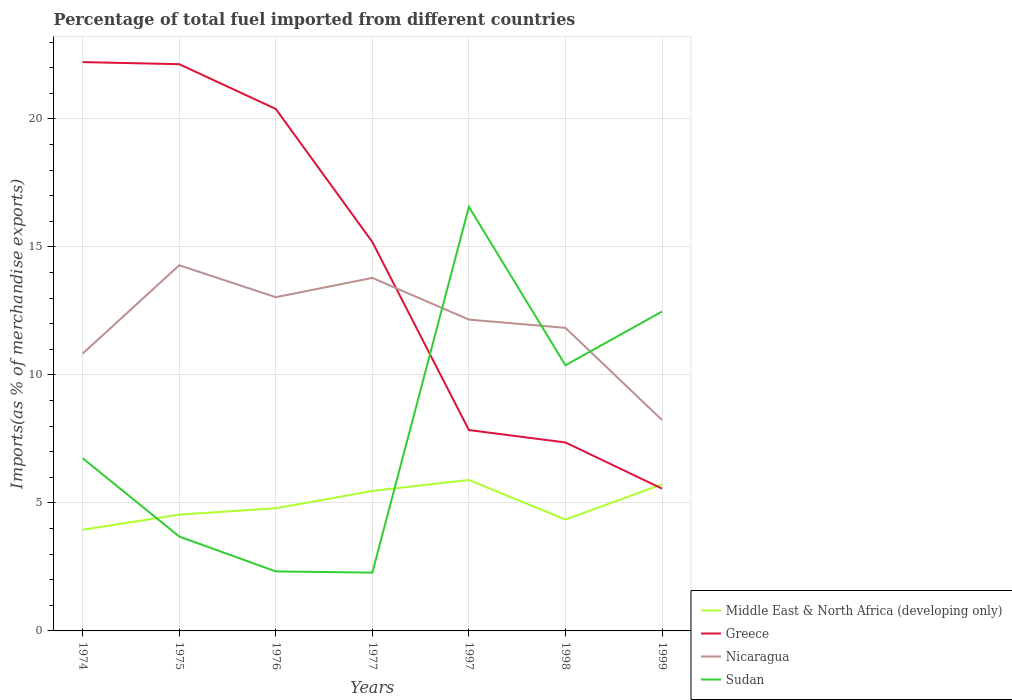How many different coloured lines are there?
Give a very brief answer. 4. Does the line corresponding to Sudan intersect with the line corresponding to Greece?
Your response must be concise. Yes. Is the number of lines equal to the number of legend labels?
Offer a very short reply. Yes. Across all years, what is the maximum percentage of imports to different countries in Nicaragua?
Your answer should be compact. 8.24. In which year was the percentage of imports to different countries in Nicaragua maximum?
Make the answer very short. 1999. What is the total percentage of imports to different countries in Nicaragua in the graph?
Your answer should be very brief. 1.25. What is the difference between the highest and the second highest percentage of imports to different countries in Middle East & North Africa (developing only)?
Offer a very short reply. 1.94. Is the percentage of imports to different countries in Greece strictly greater than the percentage of imports to different countries in Sudan over the years?
Make the answer very short. No. What is the difference between two consecutive major ticks on the Y-axis?
Make the answer very short. 5. Does the graph contain any zero values?
Make the answer very short. No. What is the title of the graph?
Provide a succinct answer. Percentage of total fuel imported from different countries. Does "Egypt, Arab Rep." appear as one of the legend labels in the graph?
Give a very brief answer. No. What is the label or title of the Y-axis?
Provide a succinct answer. Imports(as % of merchandise exports). What is the Imports(as % of merchandise exports) in Middle East & North Africa (developing only) in 1974?
Give a very brief answer. 3.95. What is the Imports(as % of merchandise exports) of Greece in 1974?
Offer a very short reply. 22.22. What is the Imports(as % of merchandise exports) of Nicaragua in 1974?
Your response must be concise. 10.83. What is the Imports(as % of merchandise exports) of Sudan in 1974?
Give a very brief answer. 6.75. What is the Imports(as % of merchandise exports) in Middle East & North Africa (developing only) in 1975?
Your answer should be very brief. 4.54. What is the Imports(as % of merchandise exports) in Greece in 1975?
Your answer should be compact. 22.14. What is the Imports(as % of merchandise exports) of Nicaragua in 1975?
Offer a very short reply. 14.28. What is the Imports(as % of merchandise exports) of Sudan in 1975?
Offer a very short reply. 3.69. What is the Imports(as % of merchandise exports) of Middle East & North Africa (developing only) in 1976?
Make the answer very short. 4.79. What is the Imports(as % of merchandise exports) of Greece in 1976?
Keep it short and to the point. 20.39. What is the Imports(as % of merchandise exports) in Nicaragua in 1976?
Give a very brief answer. 13.04. What is the Imports(as % of merchandise exports) of Sudan in 1976?
Your response must be concise. 2.32. What is the Imports(as % of merchandise exports) of Middle East & North Africa (developing only) in 1977?
Provide a succinct answer. 5.47. What is the Imports(as % of merchandise exports) in Greece in 1977?
Provide a short and direct response. 15.19. What is the Imports(as % of merchandise exports) of Nicaragua in 1977?
Ensure brevity in your answer.  13.79. What is the Imports(as % of merchandise exports) in Sudan in 1977?
Ensure brevity in your answer.  2.28. What is the Imports(as % of merchandise exports) of Middle East & North Africa (developing only) in 1997?
Ensure brevity in your answer.  5.9. What is the Imports(as % of merchandise exports) in Greece in 1997?
Provide a succinct answer. 7.85. What is the Imports(as % of merchandise exports) in Nicaragua in 1997?
Your answer should be very brief. 12.16. What is the Imports(as % of merchandise exports) in Sudan in 1997?
Your response must be concise. 16.57. What is the Imports(as % of merchandise exports) in Middle East & North Africa (developing only) in 1998?
Offer a terse response. 4.35. What is the Imports(as % of merchandise exports) in Greece in 1998?
Your answer should be very brief. 7.36. What is the Imports(as % of merchandise exports) in Nicaragua in 1998?
Give a very brief answer. 11.84. What is the Imports(as % of merchandise exports) in Sudan in 1998?
Your answer should be compact. 10.38. What is the Imports(as % of merchandise exports) of Middle East & North Africa (developing only) in 1999?
Offer a very short reply. 5.72. What is the Imports(as % of merchandise exports) in Greece in 1999?
Offer a very short reply. 5.56. What is the Imports(as % of merchandise exports) of Nicaragua in 1999?
Give a very brief answer. 8.24. What is the Imports(as % of merchandise exports) of Sudan in 1999?
Offer a very short reply. 12.48. Across all years, what is the maximum Imports(as % of merchandise exports) in Middle East & North Africa (developing only)?
Offer a very short reply. 5.9. Across all years, what is the maximum Imports(as % of merchandise exports) of Greece?
Your answer should be very brief. 22.22. Across all years, what is the maximum Imports(as % of merchandise exports) in Nicaragua?
Your answer should be compact. 14.28. Across all years, what is the maximum Imports(as % of merchandise exports) of Sudan?
Your answer should be compact. 16.57. Across all years, what is the minimum Imports(as % of merchandise exports) in Middle East & North Africa (developing only)?
Your answer should be very brief. 3.95. Across all years, what is the minimum Imports(as % of merchandise exports) of Greece?
Your answer should be compact. 5.56. Across all years, what is the minimum Imports(as % of merchandise exports) of Nicaragua?
Ensure brevity in your answer.  8.24. Across all years, what is the minimum Imports(as % of merchandise exports) of Sudan?
Provide a short and direct response. 2.28. What is the total Imports(as % of merchandise exports) of Middle East & North Africa (developing only) in the graph?
Your response must be concise. 34.73. What is the total Imports(as % of merchandise exports) in Greece in the graph?
Keep it short and to the point. 100.71. What is the total Imports(as % of merchandise exports) of Nicaragua in the graph?
Ensure brevity in your answer.  84.18. What is the total Imports(as % of merchandise exports) in Sudan in the graph?
Make the answer very short. 54.45. What is the difference between the Imports(as % of merchandise exports) of Middle East & North Africa (developing only) in 1974 and that in 1975?
Ensure brevity in your answer.  -0.59. What is the difference between the Imports(as % of merchandise exports) of Greece in 1974 and that in 1975?
Make the answer very short. 0.08. What is the difference between the Imports(as % of merchandise exports) in Nicaragua in 1974 and that in 1975?
Your answer should be compact. -3.45. What is the difference between the Imports(as % of merchandise exports) in Sudan in 1974 and that in 1975?
Your response must be concise. 3.06. What is the difference between the Imports(as % of merchandise exports) of Middle East & North Africa (developing only) in 1974 and that in 1976?
Your answer should be very brief. -0.84. What is the difference between the Imports(as % of merchandise exports) in Greece in 1974 and that in 1976?
Your response must be concise. 1.83. What is the difference between the Imports(as % of merchandise exports) of Nicaragua in 1974 and that in 1976?
Provide a succinct answer. -2.2. What is the difference between the Imports(as % of merchandise exports) in Sudan in 1974 and that in 1976?
Make the answer very short. 4.42. What is the difference between the Imports(as % of merchandise exports) of Middle East & North Africa (developing only) in 1974 and that in 1977?
Keep it short and to the point. -1.51. What is the difference between the Imports(as % of merchandise exports) of Greece in 1974 and that in 1977?
Ensure brevity in your answer.  7.03. What is the difference between the Imports(as % of merchandise exports) in Nicaragua in 1974 and that in 1977?
Your answer should be very brief. -2.96. What is the difference between the Imports(as % of merchandise exports) in Sudan in 1974 and that in 1977?
Provide a succinct answer. 4.47. What is the difference between the Imports(as % of merchandise exports) of Middle East & North Africa (developing only) in 1974 and that in 1997?
Your answer should be compact. -1.94. What is the difference between the Imports(as % of merchandise exports) in Greece in 1974 and that in 1997?
Provide a succinct answer. 14.37. What is the difference between the Imports(as % of merchandise exports) in Nicaragua in 1974 and that in 1997?
Ensure brevity in your answer.  -1.33. What is the difference between the Imports(as % of merchandise exports) of Sudan in 1974 and that in 1997?
Your answer should be compact. -9.82. What is the difference between the Imports(as % of merchandise exports) in Middle East & North Africa (developing only) in 1974 and that in 1998?
Your answer should be compact. -0.4. What is the difference between the Imports(as % of merchandise exports) of Greece in 1974 and that in 1998?
Provide a short and direct response. 14.86. What is the difference between the Imports(as % of merchandise exports) of Nicaragua in 1974 and that in 1998?
Offer a very short reply. -1. What is the difference between the Imports(as % of merchandise exports) of Sudan in 1974 and that in 1998?
Provide a succinct answer. -3.63. What is the difference between the Imports(as % of merchandise exports) in Middle East & North Africa (developing only) in 1974 and that in 1999?
Your answer should be very brief. -1.77. What is the difference between the Imports(as % of merchandise exports) of Greece in 1974 and that in 1999?
Keep it short and to the point. 16.66. What is the difference between the Imports(as % of merchandise exports) in Nicaragua in 1974 and that in 1999?
Provide a succinct answer. 2.6. What is the difference between the Imports(as % of merchandise exports) of Sudan in 1974 and that in 1999?
Offer a very short reply. -5.73. What is the difference between the Imports(as % of merchandise exports) of Middle East & North Africa (developing only) in 1975 and that in 1976?
Provide a succinct answer. -0.25. What is the difference between the Imports(as % of merchandise exports) of Greece in 1975 and that in 1976?
Offer a very short reply. 1.75. What is the difference between the Imports(as % of merchandise exports) in Nicaragua in 1975 and that in 1976?
Your response must be concise. 1.25. What is the difference between the Imports(as % of merchandise exports) of Sudan in 1975 and that in 1976?
Keep it short and to the point. 1.36. What is the difference between the Imports(as % of merchandise exports) in Middle East & North Africa (developing only) in 1975 and that in 1977?
Ensure brevity in your answer.  -0.92. What is the difference between the Imports(as % of merchandise exports) in Greece in 1975 and that in 1977?
Your answer should be compact. 6.94. What is the difference between the Imports(as % of merchandise exports) in Nicaragua in 1975 and that in 1977?
Keep it short and to the point. 0.49. What is the difference between the Imports(as % of merchandise exports) of Sudan in 1975 and that in 1977?
Offer a terse response. 1.41. What is the difference between the Imports(as % of merchandise exports) in Middle East & North Africa (developing only) in 1975 and that in 1997?
Give a very brief answer. -1.35. What is the difference between the Imports(as % of merchandise exports) of Greece in 1975 and that in 1997?
Make the answer very short. 14.29. What is the difference between the Imports(as % of merchandise exports) of Nicaragua in 1975 and that in 1997?
Ensure brevity in your answer.  2.12. What is the difference between the Imports(as % of merchandise exports) of Sudan in 1975 and that in 1997?
Keep it short and to the point. -12.88. What is the difference between the Imports(as % of merchandise exports) of Middle East & North Africa (developing only) in 1975 and that in 1998?
Provide a succinct answer. 0.19. What is the difference between the Imports(as % of merchandise exports) of Greece in 1975 and that in 1998?
Your answer should be compact. 14.78. What is the difference between the Imports(as % of merchandise exports) in Nicaragua in 1975 and that in 1998?
Make the answer very short. 2.45. What is the difference between the Imports(as % of merchandise exports) in Sudan in 1975 and that in 1998?
Provide a short and direct response. -6.69. What is the difference between the Imports(as % of merchandise exports) in Middle East & North Africa (developing only) in 1975 and that in 1999?
Give a very brief answer. -1.18. What is the difference between the Imports(as % of merchandise exports) of Greece in 1975 and that in 1999?
Your answer should be very brief. 16.58. What is the difference between the Imports(as % of merchandise exports) in Nicaragua in 1975 and that in 1999?
Offer a very short reply. 6.05. What is the difference between the Imports(as % of merchandise exports) in Sudan in 1975 and that in 1999?
Offer a very short reply. -8.79. What is the difference between the Imports(as % of merchandise exports) in Middle East & North Africa (developing only) in 1976 and that in 1977?
Give a very brief answer. -0.68. What is the difference between the Imports(as % of merchandise exports) in Greece in 1976 and that in 1977?
Your response must be concise. 5.2. What is the difference between the Imports(as % of merchandise exports) in Nicaragua in 1976 and that in 1977?
Offer a very short reply. -0.75. What is the difference between the Imports(as % of merchandise exports) of Sudan in 1976 and that in 1977?
Provide a succinct answer. 0.05. What is the difference between the Imports(as % of merchandise exports) in Middle East & North Africa (developing only) in 1976 and that in 1997?
Ensure brevity in your answer.  -1.11. What is the difference between the Imports(as % of merchandise exports) in Greece in 1976 and that in 1997?
Provide a succinct answer. 12.54. What is the difference between the Imports(as % of merchandise exports) of Nicaragua in 1976 and that in 1997?
Provide a short and direct response. 0.88. What is the difference between the Imports(as % of merchandise exports) of Sudan in 1976 and that in 1997?
Your response must be concise. -14.24. What is the difference between the Imports(as % of merchandise exports) in Middle East & North Africa (developing only) in 1976 and that in 1998?
Offer a very short reply. 0.44. What is the difference between the Imports(as % of merchandise exports) in Greece in 1976 and that in 1998?
Offer a very short reply. 13.03. What is the difference between the Imports(as % of merchandise exports) of Nicaragua in 1976 and that in 1998?
Provide a succinct answer. 1.2. What is the difference between the Imports(as % of merchandise exports) in Sudan in 1976 and that in 1998?
Provide a succinct answer. -8.05. What is the difference between the Imports(as % of merchandise exports) in Middle East & North Africa (developing only) in 1976 and that in 1999?
Make the answer very short. -0.93. What is the difference between the Imports(as % of merchandise exports) of Greece in 1976 and that in 1999?
Your answer should be compact. 14.83. What is the difference between the Imports(as % of merchandise exports) in Nicaragua in 1976 and that in 1999?
Provide a succinct answer. 4.8. What is the difference between the Imports(as % of merchandise exports) of Sudan in 1976 and that in 1999?
Give a very brief answer. -10.15. What is the difference between the Imports(as % of merchandise exports) in Middle East & North Africa (developing only) in 1977 and that in 1997?
Provide a short and direct response. -0.43. What is the difference between the Imports(as % of merchandise exports) of Greece in 1977 and that in 1997?
Offer a very short reply. 7.35. What is the difference between the Imports(as % of merchandise exports) in Nicaragua in 1977 and that in 1997?
Your answer should be very brief. 1.63. What is the difference between the Imports(as % of merchandise exports) in Sudan in 1977 and that in 1997?
Make the answer very short. -14.29. What is the difference between the Imports(as % of merchandise exports) in Middle East & North Africa (developing only) in 1977 and that in 1998?
Your answer should be very brief. 1.12. What is the difference between the Imports(as % of merchandise exports) of Greece in 1977 and that in 1998?
Make the answer very short. 7.83. What is the difference between the Imports(as % of merchandise exports) in Nicaragua in 1977 and that in 1998?
Offer a very short reply. 1.95. What is the difference between the Imports(as % of merchandise exports) of Sudan in 1977 and that in 1998?
Offer a very short reply. -8.1. What is the difference between the Imports(as % of merchandise exports) in Middle East & North Africa (developing only) in 1977 and that in 1999?
Your response must be concise. -0.26. What is the difference between the Imports(as % of merchandise exports) of Greece in 1977 and that in 1999?
Offer a terse response. 9.63. What is the difference between the Imports(as % of merchandise exports) of Nicaragua in 1977 and that in 1999?
Provide a succinct answer. 5.55. What is the difference between the Imports(as % of merchandise exports) of Sudan in 1977 and that in 1999?
Offer a very short reply. -10.2. What is the difference between the Imports(as % of merchandise exports) in Middle East & North Africa (developing only) in 1997 and that in 1998?
Ensure brevity in your answer.  1.55. What is the difference between the Imports(as % of merchandise exports) of Greece in 1997 and that in 1998?
Provide a short and direct response. 0.48. What is the difference between the Imports(as % of merchandise exports) of Nicaragua in 1997 and that in 1998?
Provide a short and direct response. 0.32. What is the difference between the Imports(as % of merchandise exports) in Sudan in 1997 and that in 1998?
Your answer should be very brief. 6.19. What is the difference between the Imports(as % of merchandise exports) of Middle East & North Africa (developing only) in 1997 and that in 1999?
Offer a terse response. 0.17. What is the difference between the Imports(as % of merchandise exports) of Greece in 1997 and that in 1999?
Offer a terse response. 2.29. What is the difference between the Imports(as % of merchandise exports) in Nicaragua in 1997 and that in 1999?
Ensure brevity in your answer.  3.92. What is the difference between the Imports(as % of merchandise exports) of Sudan in 1997 and that in 1999?
Offer a very short reply. 4.09. What is the difference between the Imports(as % of merchandise exports) of Middle East & North Africa (developing only) in 1998 and that in 1999?
Give a very brief answer. -1.37. What is the difference between the Imports(as % of merchandise exports) of Greece in 1998 and that in 1999?
Ensure brevity in your answer.  1.8. What is the difference between the Imports(as % of merchandise exports) of Nicaragua in 1998 and that in 1999?
Ensure brevity in your answer.  3.6. What is the difference between the Imports(as % of merchandise exports) in Sudan in 1998 and that in 1999?
Keep it short and to the point. -2.1. What is the difference between the Imports(as % of merchandise exports) in Middle East & North Africa (developing only) in 1974 and the Imports(as % of merchandise exports) in Greece in 1975?
Offer a very short reply. -18.18. What is the difference between the Imports(as % of merchandise exports) of Middle East & North Africa (developing only) in 1974 and the Imports(as % of merchandise exports) of Nicaragua in 1975?
Keep it short and to the point. -10.33. What is the difference between the Imports(as % of merchandise exports) in Middle East & North Africa (developing only) in 1974 and the Imports(as % of merchandise exports) in Sudan in 1975?
Keep it short and to the point. 0.27. What is the difference between the Imports(as % of merchandise exports) in Greece in 1974 and the Imports(as % of merchandise exports) in Nicaragua in 1975?
Keep it short and to the point. 7.94. What is the difference between the Imports(as % of merchandise exports) in Greece in 1974 and the Imports(as % of merchandise exports) in Sudan in 1975?
Give a very brief answer. 18.53. What is the difference between the Imports(as % of merchandise exports) of Nicaragua in 1974 and the Imports(as % of merchandise exports) of Sudan in 1975?
Keep it short and to the point. 7.15. What is the difference between the Imports(as % of merchandise exports) of Middle East & North Africa (developing only) in 1974 and the Imports(as % of merchandise exports) of Greece in 1976?
Offer a terse response. -16.44. What is the difference between the Imports(as % of merchandise exports) of Middle East & North Africa (developing only) in 1974 and the Imports(as % of merchandise exports) of Nicaragua in 1976?
Your answer should be very brief. -9.08. What is the difference between the Imports(as % of merchandise exports) in Middle East & North Africa (developing only) in 1974 and the Imports(as % of merchandise exports) in Sudan in 1976?
Offer a very short reply. 1.63. What is the difference between the Imports(as % of merchandise exports) of Greece in 1974 and the Imports(as % of merchandise exports) of Nicaragua in 1976?
Offer a terse response. 9.18. What is the difference between the Imports(as % of merchandise exports) of Greece in 1974 and the Imports(as % of merchandise exports) of Sudan in 1976?
Make the answer very short. 19.89. What is the difference between the Imports(as % of merchandise exports) of Nicaragua in 1974 and the Imports(as % of merchandise exports) of Sudan in 1976?
Provide a short and direct response. 8.51. What is the difference between the Imports(as % of merchandise exports) of Middle East & North Africa (developing only) in 1974 and the Imports(as % of merchandise exports) of Greece in 1977?
Offer a terse response. -11.24. What is the difference between the Imports(as % of merchandise exports) of Middle East & North Africa (developing only) in 1974 and the Imports(as % of merchandise exports) of Nicaragua in 1977?
Give a very brief answer. -9.84. What is the difference between the Imports(as % of merchandise exports) of Middle East & North Africa (developing only) in 1974 and the Imports(as % of merchandise exports) of Sudan in 1977?
Make the answer very short. 1.68. What is the difference between the Imports(as % of merchandise exports) of Greece in 1974 and the Imports(as % of merchandise exports) of Nicaragua in 1977?
Provide a succinct answer. 8.43. What is the difference between the Imports(as % of merchandise exports) of Greece in 1974 and the Imports(as % of merchandise exports) of Sudan in 1977?
Offer a terse response. 19.94. What is the difference between the Imports(as % of merchandise exports) in Nicaragua in 1974 and the Imports(as % of merchandise exports) in Sudan in 1977?
Offer a terse response. 8.56. What is the difference between the Imports(as % of merchandise exports) in Middle East & North Africa (developing only) in 1974 and the Imports(as % of merchandise exports) in Greece in 1997?
Your answer should be compact. -3.89. What is the difference between the Imports(as % of merchandise exports) in Middle East & North Africa (developing only) in 1974 and the Imports(as % of merchandise exports) in Nicaragua in 1997?
Give a very brief answer. -8.21. What is the difference between the Imports(as % of merchandise exports) of Middle East & North Africa (developing only) in 1974 and the Imports(as % of merchandise exports) of Sudan in 1997?
Make the answer very short. -12.61. What is the difference between the Imports(as % of merchandise exports) in Greece in 1974 and the Imports(as % of merchandise exports) in Nicaragua in 1997?
Offer a very short reply. 10.06. What is the difference between the Imports(as % of merchandise exports) of Greece in 1974 and the Imports(as % of merchandise exports) of Sudan in 1997?
Ensure brevity in your answer.  5.65. What is the difference between the Imports(as % of merchandise exports) of Nicaragua in 1974 and the Imports(as % of merchandise exports) of Sudan in 1997?
Provide a short and direct response. -5.73. What is the difference between the Imports(as % of merchandise exports) of Middle East & North Africa (developing only) in 1974 and the Imports(as % of merchandise exports) of Greece in 1998?
Your answer should be compact. -3.41. What is the difference between the Imports(as % of merchandise exports) in Middle East & North Africa (developing only) in 1974 and the Imports(as % of merchandise exports) in Nicaragua in 1998?
Keep it short and to the point. -7.89. What is the difference between the Imports(as % of merchandise exports) in Middle East & North Africa (developing only) in 1974 and the Imports(as % of merchandise exports) in Sudan in 1998?
Ensure brevity in your answer.  -6.42. What is the difference between the Imports(as % of merchandise exports) in Greece in 1974 and the Imports(as % of merchandise exports) in Nicaragua in 1998?
Offer a very short reply. 10.38. What is the difference between the Imports(as % of merchandise exports) in Greece in 1974 and the Imports(as % of merchandise exports) in Sudan in 1998?
Ensure brevity in your answer.  11.84. What is the difference between the Imports(as % of merchandise exports) in Nicaragua in 1974 and the Imports(as % of merchandise exports) in Sudan in 1998?
Your answer should be compact. 0.46. What is the difference between the Imports(as % of merchandise exports) of Middle East & North Africa (developing only) in 1974 and the Imports(as % of merchandise exports) of Greece in 1999?
Make the answer very short. -1.61. What is the difference between the Imports(as % of merchandise exports) of Middle East & North Africa (developing only) in 1974 and the Imports(as % of merchandise exports) of Nicaragua in 1999?
Give a very brief answer. -4.28. What is the difference between the Imports(as % of merchandise exports) in Middle East & North Africa (developing only) in 1974 and the Imports(as % of merchandise exports) in Sudan in 1999?
Your answer should be very brief. -8.52. What is the difference between the Imports(as % of merchandise exports) in Greece in 1974 and the Imports(as % of merchandise exports) in Nicaragua in 1999?
Your response must be concise. 13.98. What is the difference between the Imports(as % of merchandise exports) of Greece in 1974 and the Imports(as % of merchandise exports) of Sudan in 1999?
Provide a succinct answer. 9.74. What is the difference between the Imports(as % of merchandise exports) in Nicaragua in 1974 and the Imports(as % of merchandise exports) in Sudan in 1999?
Keep it short and to the point. -1.64. What is the difference between the Imports(as % of merchandise exports) of Middle East & North Africa (developing only) in 1975 and the Imports(as % of merchandise exports) of Greece in 1976?
Keep it short and to the point. -15.85. What is the difference between the Imports(as % of merchandise exports) in Middle East & North Africa (developing only) in 1975 and the Imports(as % of merchandise exports) in Nicaragua in 1976?
Your response must be concise. -8.49. What is the difference between the Imports(as % of merchandise exports) in Middle East & North Africa (developing only) in 1975 and the Imports(as % of merchandise exports) in Sudan in 1976?
Provide a succinct answer. 2.22. What is the difference between the Imports(as % of merchandise exports) of Greece in 1975 and the Imports(as % of merchandise exports) of Nicaragua in 1976?
Provide a short and direct response. 9.1. What is the difference between the Imports(as % of merchandise exports) in Greece in 1975 and the Imports(as % of merchandise exports) in Sudan in 1976?
Ensure brevity in your answer.  19.81. What is the difference between the Imports(as % of merchandise exports) of Nicaragua in 1975 and the Imports(as % of merchandise exports) of Sudan in 1976?
Give a very brief answer. 11.96. What is the difference between the Imports(as % of merchandise exports) in Middle East & North Africa (developing only) in 1975 and the Imports(as % of merchandise exports) in Greece in 1977?
Make the answer very short. -10.65. What is the difference between the Imports(as % of merchandise exports) of Middle East & North Africa (developing only) in 1975 and the Imports(as % of merchandise exports) of Nicaragua in 1977?
Make the answer very short. -9.25. What is the difference between the Imports(as % of merchandise exports) in Middle East & North Africa (developing only) in 1975 and the Imports(as % of merchandise exports) in Sudan in 1977?
Give a very brief answer. 2.27. What is the difference between the Imports(as % of merchandise exports) of Greece in 1975 and the Imports(as % of merchandise exports) of Nicaragua in 1977?
Ensure brevity in your answer.  8.35. What is the difference between the Imports(as % of merchandise exports) in Greece in 1975 and the Imports(as % of merchandise exports) in Sudan in 1977?
Your answer should be very brief. 19.86. What is the difference between the Imports(as % of merchandise exports) of Nicaragua in 1975 and the Imports(as % of merchandise exports) of Sudan in 1977?
Provide a short and direct response. 12.01. What is the difference between the Imports(as % of merchandise exports) in Middle East & North Africa (developing only) in 1975 and the Imports(as % of merchandise exports) in Greece in 1997?
Your answer should be compact. -3.3. What is the difference between the Imports(as % of merchandise exports) of Middle East & North Africa (developing only) in 1975 and the Imports(as % of merchandise exports) of Nicaragua in 1997?
Your response must be concise. -7.62. What is the difference between the Imports(as % of merchandise exports) of Middle East & North Africa (developing only) in 1975 and the Imports(as % of merchandise exports) of Sudan in 1997?
Provide a short and direct response. -12.02. What is the difference between the Imports(as % of merchandise exports) of Greece in 1975 and the Imports(as % of merchandise exports) of Nicaragua in 1997?
Make the answer very short. 9.98. What is the difference between the Imports(as % of merchandise exports) in Greece in 1975 and the Imports(as % of merchandise exports) in Sudan in 1997?
Make the answer very short. 5.57. What is the difference between the Imports(as % of merchandise exports) in Nicaragua in 1975 and the Imports(as % of merchandise exports) in Sudan in 1997?
Provide a succinct answer. -2.28. What is the difference between the Imports(as % of merchandise exports) in Middle East & North Africa (developing only) in 1975 and the Imports(as % of merchandise exports) in Greece in 1998?
Keep it short and to the point. -2.82. What is the difference between the Imports(as % of merchandise exports) of Middle East & North Africa (developing only) in 1975 and the Imports(as % of merchandise exports) of Nicaragua in 1998?
Your answer should be compact. -7.3. What is the difference between the Imports(as % of merchandise exports) in Middle East & North Africa (developing only) in 1975 and the Imports(as % of merchandise exports) in Sudan in 1998?
Make the answer very short. -5.83. What is the difference between the Imports(as % of merchandise exports) of Greece in 1975 and the Imports(as % of merchandise exports) of Nicaragua in 1998?
Provide a short and direct response. 10.3. What is the difference between the Imports(as % of merchandise exports) in Greece in 1975 and the Imports(as % of merchandise exports) in Sudan in 1998?
Give a very brief answer. 11.76. What is the difference between the Imports(as % of merchandise exports) in Nicaragua in 1975 and the Imports(as % of merchandise exports) in Sudan in 1998?
Your answer should be compact. 3.91. What is the difference between the Imports(as % of merchandise exports) of Middle East & North Africa (developing only) in 1975 and the Imports(as % of merchandise exports) of Greece in 1999?
Offer a very short reply. -1.02. What is the difference between the Imports(as % of merchandise exports) in Middle East & North Africa (developing only) in 1975 and the Imports(as % of merchandise exports) in Nicaragua in 1999?
Ensure brevity in your answer.  -3.7. What is the difference between the Imports(as % of merchandise exports) in Middle East & North Africa (developing only) in 1975 and the Imports(as % of merchandise exports) in Sudan in 1999?
Give a very brief answer. -7.93. What is the difference between the Imports(as % of merchandise exports) of Greece in 1975 and the Imports(as % of merchandise exports) of Nicaragua in 1999?
Keep it short and to the point. 13.9. What is the difference between the Imports(as % of merchandise exports) in Greece in 1975 and the Imports(as % of merchandise exports) in Sudan in 1999?
Give a very brief answer. 9.66. What is the difference between the Imports(as % of merchandise exports) in Nicaragua in 1975 and the Imports(as % of merchandise exports) in Sudan in 1999?
Provide a short and direct response. 1.81. What is the difference between the Imports(as % of merchandise exports) of Middle East & North Africa (developing only) in 1976 and the Imports(as % of merchandise exports) of Greece in 1977?
Give a very brief answer. -10.4. What is the difference between the Imports(as % of merchandise exports) in Middle East & North Africa (developing only) in 1976 and the Imports(as % of merchandise exports) in Nicaragua in 1977?
Your response must be concise. -9. What is the difference between the Imports(as % of merchandise exports) in Middle East & North Africa (developing only) in 1976 and the Imports(as % of merchandise exports) in Sudan in 1977?
Your response must be concise. 2.51. What is the difference between the Imports(as % of merchandise exports) in Greece in 1976 and the Imports(as % of merchandise exports) in Nicaragua in 1977?
Keep it short and to the point. 6.6. What is the difference between the Imports(as % of merchandise exports) in Greece in 1976 and the Imports(as % of merchandise exports) in Sudan in 1977?
Provide a short and direct response. 18.11. What is the difference between the Imports(as % of merchandise exports) of Nicaragua in 1976 and the Imports(as % of merchandise exports) of Sudan in 1977?
Provide a succinct answer. 10.76. What is the difference between the Imports(as % of merchandise exports) in Middle East & North Africa (developing only) in 1976 and the Imports(as % of merchandise exports) in Greece in 1997?
Offer a terse response. -3.05. What is the difference between the Imports(as % of merchandise exports) of Middle East & North Africa (developing only) in 1976 and the Imports(as % of merchandise exports) of Nicaragua in 1997?
Offer a very short reply. -7.37. What is the difference between the Imports(as % of merchandise exports) in Middle East & North Africa (developing only) in 1976 and the Imports(as % of merchandise exports) in Sudan in 1997?
Provide a short and direct response. -11.78. What is the difference between the Imports(as % of merchandise exports) in Greece in 1976 and the Imports(as % of merchandise exports) in Nicaragua in 1997?
Keep it short and to the point. 8.23. What is the difference between the Imports(as % of merchandise exports) of Greece in 1976 and the Imports(as % of merchandise exports) of Sudan in 1997?
Ensure brevity in your answer.  3.82. What is the difference between the Imports(as % of merchandise exports) of Nicaragua in 1976 and the Imports(as % of merchandise exports) of Sudan in 1997?
Offer a very short reply. -3.53. What is the difference between the Imports(as % of merchandise exports) of Middle East & North Africa (developing only) in 1976 and the Imports(as % of merchandise exports) of Greece in 1998?
Your answer should be compact. -2.57. What is the difference between the Imports(as % of merchandise exports) of Middle East & North Africa (developing only) in 1976 and the Imports(as % of merchandise exports) of Nicaragua in 1998?
Offer a very short reply. -7.05. What is the difference between the Imports(as % of merchandise exports) of Middle East & North Africa (developing only) in 1976 and the Imports(as % of merchandise exports) of Sudan in 1998?
Offer a very short reply. -5.59. What is the difference between the Imports(as % of merchandise exports) in Greece in 1976 and the Imports(as % of merchandise exports) in Nicaragua in 1998?
Your answer should be compact. 8.55. What is the difference between the Imports(as % of merchandise exports) of Greece in 1976 and the Imports(as % of merchandise exports) of Sudan in 1998?
Ensure brevity in your answer.  10.01. What is the difference between the Imports(as % of merchandise exports) in Nicaragua in 1976 and the Imports(as % of merchandise exports) in Sudan in 1998?
Offer a very short reply. 2.66. What is the difference between the Imports(as % of merchandise exports) of Middle East & North Africa (developing only) in 1976 and the Imports(as % of merchandise exports) of Greece in 1999?
Offer a very short reply. -0.77. What is the difference between the Imports(as % of merchandise exports) of Middle East & North Africa (developing only) in 1976 and the Imports(as % of merchandise exports) of Nicaragua in 1999?
Provide a succinct answer. -3.45. What is the difference between the Imports(as % of merchandise exports) in Middle East & North Africa (developing only) in 1976 and the Imports(as % of merchandise exports) in Sudan in 1999?
Ensure brevity in your answer.  -7.68. What is the difference between the Imports(as % of merchandise exports) of Greece in 1976 and the Imports(as % of merchandise exports) of Nicaragua in 1999?
Keep it short and to the point. 12.15. What is the difference between the Imports(as % of merchandise exports) of Greece in 1976 and the Imports(as % of merchandise exports) of Sudan in 1999?
Offer a terse response. 7.91. What is the difference between the Imports(as % of merchandise exports) in Nicaragua in 1976 and the Imports(as % of merchandise exports) in Sudan in 1999?
Give a very brief answer. 0.56. What is the difference between the Imports(as % of merchandise exports) of Middle East & North Africa (developing only) in 1977 and the Imports(as % of merchandise exports) of Greece in 1997?
Your answer should be very brief. -2.38. What is the difference between the Imports(as % of merchandise exports) in Middle East & North Africa (developing only) in 1977 and the Imports(as % of merchandise exports) in Nicaragua in 1997?
Make the answer very short. -6.69. What is the difference between the Imports(as % of merchandise exports) of Middle East & North Africa (developing only) in 1977 and the Imports(as % of merchandise exports) of Sudan in 1997?
Ensure brevity in your answer.  -11.1. What is the difference between the Imports(as % of merchandise exports) of Greece in 1977 and the Imports(as % of merchandise exports) of Nicaragua in 1997?
Make the answer very short. 3.03. What is the difference between the Imports(as % of merchandise exports) in Greece in 1977 and the Imports(as % of merchandise exports) in Sudan in 1997?
Your answer should be compact. -1.37. What is the difference between the Imports(as % of merchandise exports) of Nicaragua in 1977 and the Imports(as % of merchandise exports) of Sudan in 1997?
Provide a succinct answer. -2.78. What is the difference between the Imports(as % of merchandise exports) of Middle East & North Africa (developing only) in 1977 and the Imports(as % of merchandise exports) of Greece in 1998?
Give a very brief answer. -1.89. What is the difference between the Imports(as % of merchandise exports) in Middle East & North Africa (developing only) in 1977 and the Imports(as % of merchandise exports) in Nicaragua in 1998?
Offer a very short reply. -6.37. What is the difference between the Imports(as % of merchandise exports) in Middle East & North Africa (developing only) in 1977 and the Imports(as % of merchandise exports) in Sudan in 1998?
Provide a succinct answer. -4.91. What is the difference between the Imports(as % of merchandise exports) of Greece in 1977 and the Imports(as % of merchandise exports) of Nicaragua in 1998?
Offer a terse response. 3.36. What is the difference between the Imports(as % of merchandise exports) of Greece in 1977 and the Imports(as % of merchandise exports) of Sudan in 1998?
Your answer should be very brief. 4.82. What is the difference between the Imports(as % of merchandise exports) of Nicaragua in 1977 and the Imports(as % of merchandise exports) of Sudan in 1998?
Make the answer very short. 3.41. What is the difference between the Imports(as % of merchandise exports) of Middle East & North Africa (developing only) in 1977 and the Imports(as % of merchandise exports) of Greece in 1999?
Offer a very short reply. -0.09. What is the difference between the Imports(as % of merchandise exports) in Middle East & North Africa (developing only) in 1977 and the Imports(as % of merchandise exports) in Nicaragua in 1999?
Offer a terse response. -2.77. What is the difference between the Imports(as % of merchandise exports) of Middle East & North Africa (developing only) in 1977 and the Imports(as % of merchandise exports) of Sudan in 1999?
Your response must be concise. -7.01. What is the difference between the Imports(as % of merchandise exports) of Greece in 1977 and the Imports(as % of merchandise exports) of Nicaragua in 1999?
Offer a terse response. 6.96. What is the difference between the Imports(as % of merchandise exports) of Greece in 1977 and the Imports(as % of merchandise exports) of Sudan in 1999?
Your answer should be very brief. 2.72. What is the difference between the Imports(as % of merchandise exports) in Nicaragua in 1977 and the Imports(as % of merchandise exports) in Sudan in 1999?
Your answer should be compact. 1.31. What is the difference between the Imports(as % of merchandise exports) in Middle East & North Africa (developing only) in 1997 and the Imports(as % of merchandise exports) in Greece in 1998?
Your response must be concise. -1.47. What is the difference between the Imports(as % of merchandise exports) in Middle East & North Africa (developing only) in 1997 and the Imports(as % of merchandise exports) in Nicaragua in 1998?
Keep it short and to the point. -5.94. What is the difference between the Imports(as % of merchandise exports) of Middle East & North Africa (developing only) in 1997 and the Imports(as % of merchandise exports) of Sudan in 1998?
Provide a succinct answer. -4.48. What is the difference between the Imports(as % of merchandise exports) of Greece in 1997 and the Imports(as % of merchandise exports) of Nicaragua in 1998?
Your answer should be compact. -3.99. What is the difference between the Imports(as % of merchandise exports) in Greece in 1997 and the Imports(as % of merchandise exports) in Sudan in 1998?
Offer a very short reply. -2.53. What is the difference between the Imports(as % of merchandise exports) of Nicaragua in 1997 and the Imports(as % of merchandise exports) of Sudan in 1998?
Your response must be concise. 1.78. What is the difference between the Imports(as % of merchandise exports) in Middle East & North Africa (developing only) in 1997 and the Imports(as % of merchandise exports) in Greece in 1999?
Your answer should be very brief. 0.34. What is the difference between the Imports(as % of merchandise exports) of Middle East & North Africa (developing only) in 1997 and the Imports(as % of merchandise exports) of Nicaragua in 1999?
Your answer should be compact. -2.34. What is the difference between the Imports(as % of merchandise exports) in Middle East & North Africa (developing only) in 1997 and the Imports(as % of merchandise exports) in Sudan in 1999?
Keep it short and to the point. -6.58. What is the difference between the Imports(as % of merchandise exports) in Greece in 1997 and the Imports(as % of merchandise exports) in Nicaragua in 1999?
Offer a terse response. -0.39. What is the difference between the Imports(as % of merchandise exports) in Greece in 1997 and the Imports(as % of merchandise exports) in Sudan in 1999?
Provide a succinct answer. -4.63. What is the difference between the Imports(as % of merchandise exports) of Nicaragua in 1997 and the Imports(as % of merchandise exports) of Sudan in 1999?
Ensure brevity in your answer.  -0.31. What is the difference between the Imports(as % of merchandise exports) in Middle East & North Africa (developing only) in 1998 and the Imports(as % of merchandise exports) in Greece in 1999?
Your answer should be compact. -1.21. What is the difference between the Imports(as % of merchandise exports) of Middle East & North Africa (developing only) in 1998 and the Imports(as % of merchandise exports) of Nicaragua in 1999?
Provide a short and direct response. -3.89. What is the difference between the Imports(as % of merchandise exports) of Middle East & North Africa (developing only) in 1998 and the Imports(as % of merchandise exports) of Sudan in 1999?
Give a very brief answer. -8.13. What is the difference between the Imports(as % of merchandise exports) in Greece in 1998 and the Imports(as % of merchandise exports) in Nicaragua in 1999?
Keep it short and to the point. -0.88. What is the difference between the Imports(as % of merchandise exports) of Greece in 1998 and the Imports(as % of merchandise exports) of Sudan in 1999?
Keep it short and to the point. -5.11. What is the difference between the Imports(as % of merchandise exports) of Nicaragua in 1998 and the Imports(as % of merchandise exports) of Sudan in 1999?
Your answer should be very brief. -0.64. What is the average Imports(as % of merchandise exports) in Middle East & North Africa (developing only) per year?
Ensure brevity in your answer.  4.96. What is the average Imports(as % of merchandise exports) in Greece per year?
Offer a terse response. 14.39. What is the average Imports(as % of merchandise exports) in Nicaragua per year?
Offer a very short reply. 12.03. What is the average Imports(as % of merchandise exports) in Sudan per year?
Keep it short and to the point. 7.78. In the year 1974, what is the difference between the Imports(as % of merchandise exports) in Middle East & North Africa (developing only) and Imports(as % of merchandise exports) in Greece?
Offer a very short reply. -18.27. In the year 1974, what is the difference between the Imports(as % of merchandise exports) of Middle East & North Africa (developing only) and Imports(as % of merchandise exports) of Nicaragua?
Give a very brief answer. -6.88. In the year 1974, what is the difference between the Imports(as % of merchandise exports) in Middle East & North Africa (developing only) and Imports(as % of merchandise exports) in Sudan?
Offer a very short reply. -2.79. In the year 1974, what is the difference between the Imports(as % of merchandise exports) of Greece and Imports(as % of merchandise exports) of Nicaragua?
Your response must be concise. 11.39. In the year 1974, what is the difference between the Imports(as % of merchandise exports) of Greece and Imports(as % of merchandise exports) of Sudan?
Your answer should be very brief. 15.47. In the year 1974, what is the difference between the Imports(as % of merchandise exports) of Nicaragua and Imports(as % of merchandise exports) of Sudan?
Provide a succinct answer. 4.09. In the year 1975, what is the difference between the Imports(as % of merchandise exports) of Middle East & North Africa (developing only) and Imports(as % of merchandise exports) of Greece?
Offer a very short reply. -17.6. In the year 1975, what is the difference between the Imports(as % of merchandise exports) in Middle East & North Africa (developing only) and Imports(as % of merchandise exports) in Nicaragua?
Keep it short and to the point. -9.74. In the year 1975, what is the difference between the Imports(as % of merchandise exports) of Middle East & North Africa (developing only) and Imports(as % of merchandise exports) of Sudan?
Offer a very short reply. 0.86. In the year 1975, what is the difference between the Imports(as % of merchandise exports) in Greece and Imports(as % of merchandise exports) in Nicaragua?
Your answer should be very brief. 7.85. In the year 1975, what is the difference between the Imports(as % of merchandise exports) in Greece and Imports(as % of merchandise exports) in Sudan?
Your response must be concise. 18.45. In the year 1975, what is the difference between the Imports(as % of merchandise exports) of Nicaragua and Imports(as % of merchandise exports) of Sudan?
Give a very brief answer. 10.6. In the year 1976, what is the difference between the Imports(as % of merchandise exports) of Middle East & North Africa (developing only) and Imports(as % of merchandise exports) of Greece?
Provide a short and direct response. -15.6. In the year 1976, what is the difference between the Imports(as % of merchandise exports) of Middle East & North Africa (developing only) and Imports(as % of merchandise exports) of Nicaragua?
Ensure brevity in your answer.  -8.25. In the year 1976, what is the difference between the Imports(as % of merchandise exports) in Middle East & North Africa (developing only) and Imports(as % of merchandise exports) in Sudan?
Your response must be concise. 2.47. In the year 1976, what is the difference between the Imports(as % of merchandise exports) of Greece and Imports(as % of merchandise exports) of Nicaragua?
Provide a short and direct response. 7.35. In the year 1976, what is the difference between the Imports(as % of merchandise exports) of Greece and Imports(as % of merchandise exports) of Sudan?
Provide a succinct answer. 18.06. In the year 1976, what is the difference between the Imports(as % of merchandise exports) of Nicaragua and Imports(as % of merchandise exports) of Sudan?
Offer a very short reply. 10.71. In the year 1977, what is the difference between the Imports(as % of merchandise exports) of Middle East & North Africa (developing only) and Imports(as % of merchandise exports) of Greece?
Provide a short and direct response. -9.73. In the year 1977, what is the difference between the Imports(as % of merchandise exports) in Middle East & North Africa (developing only) and Imports(as % of merchandise exports) in Nicaragua?
Provide a succinct answer. -8.32. In the year 1977, what is the difference between the Imports(as % of merchandise exports) in Middle East & North Africa (developing only) and Imports(as % of merchandise exports) in Sudan?
Keep it short and to the point. 3.19. In the year 1977, what is the difference between the Imports(as % of merchandise exports) of Greece and Imports(as % of merchandise exports) of Nicaragua?
Make the answer very short. 1.4. In the year 1977, what is the difference between the Imports(as % of merchandise exports) of Greece and Imports(as % of merchandise exports) of Sudan?
Your answer should be very brief. 12.92. In the year 1977, what is the difference between the Imports(as % of merchandise exports) in Nicaragua and Imports(as % of merchandise exports) in Sudan?
Offer a terse response. 11.51. In the year 1997, what is the difference between the Imports(as % of merchandise exports) of Middle East & North Africa (developing only) and Imports(as % of merchandise exports) of Greece?
Your answer should be compact. -1.95. In the year 1997, what is the difference between the Imports(as % of merchandise exports) in Middle East & North Africa (developing only) and Imports(as % of merchandise exports) in Nicaragua?
Offer a very short reply. -6.26. In the year 1997, what is the difference between the Imports(as % of merchandise exports) in Middle East & North Africa (developing only) and Imports(as % of merchandise exports) in Sudan?
Provide a succinct answer. -10.67. In the year 1997, what is the difference between the Imports(as % of merchandise exports) in Greece and Imports(as % of merchandise exports) in Nicaragua?
Offer a very short reply. -4.31. In the year 1997, what is the difference between the Imports(as % of merchandise exports) in Greece and Imports(as % of merchandise exports) in Sudan?
Your answer should be very brief. -8.72. In the year 1997, what is the difference between the Imports(as % of merchandise exports) of Nicaragua and Imports(as % of merchandise exports) of Sudan?
Provide a short and direct response. -4.41. In the year 1998, what is the difference between the Imports(as % of merchandise exports) in Middle East & North Africa (developing only) and Imports(as % of merchandise exports) in Greece?
Provide a short and direct response. -3.01. In the year 1998, what is the difference between the Imports(as % of merchandise exports) of Middle East & North Africa (developing only) and Imports(as % of merchandise exports) of Nicaragua?
Keep it short and to the point. -7.49. In the year 1998, what is the difference between the Imports(as % of merchandise exports) in Middle East & North Africa (developing only) and Imports(as % of merchandise exports) in Sudan?
Provide a succinct answer. -6.03. In the year 1998, what is the difference between the Imports(as % of merchandise exports) in Greece and Imports(as % of merchandise exports) in Nicaragua?
Ensure brevity in your answer.  -4.48. In the year 1998, what is the difference between the Imports(as % of merchandise exports) in Greece and Imports(as % of merchandise exports) in Sudan?
Your answer should be very brief. -3.02. In the year 1998, what is the difference between the Imports(as % of merchandise exports) in Nicaragua and Imports(as % of merchandise exports) in Sudan?
Offer a very short reply. 1.46. In the year 1999, what is the difference between the Imports(as % of merchandise exports) of Middle East & North Africa (developing only) and Imports(as % of merchandise exports) of Greece?
Your answer should be very brief. 0.16. In the year 1999, what is the difference between the Imports(as % of merchandise exports) in Middle East & North Africa (developing only) and Imports(as % of merchandise exports) in Nicaragua?
Offer a very short reply. -2.51. In the year 1999, what is the difference between the Imports(as % of merchandise exports) of Middle East & North Africa (developing only) and Imports(as % of merchandise exports) of Sudan?
Provide a succinct answer. -6.75. In the year 1999, what is the difference between the Imports(as % of merchandise exports) in Greece and Imports(as % of merchandise exports) in Nicaragua?
Your answer should be compact. -2.68. In the year 1999, what is the difference between the Imports(as % of merchandise exports) of Greece and Imports(as % of merchandise exports) of Sudan?
Offer a very short reply. -6.92. In the year 1999, what is the difference between the Imports(as % of merchandise exports) in Nicaragua and Imports(as % of merchandise exports) in Sudan?
Offer a terse response. -4.24. What is the ratio of the Imports(as % of merchandise exports) in Middle East & North Africa (developing only) in 1974 to that in 1975?
Provide a succinct answer. 0.87. What is the ratio of the Imports(as % of merchandise exports) in Greece in 1974 to that in 1975?
Your answer should be compact. 1. What is the ratio of the Imports(as % of merchandise exports) in Nicaragua in 1974 to that in 1975?
Provide a succinct answer. 0.76. What is the ratio of the Imports(as % of merchandise exports) of Sudan in 1974 to that in 1975?
Provide a succinct answer. 1.83. What is the ratio of the Imports(as % of merchandise exports) of Middle East & North Africa (developing only) in 1974 to that in 1976?
Offer a terse response. 0.82. What is the ratio of the Imports(as % of merchandise exports) of Greece in 1974 to that in 1976?
Provide a succinct answer. 1.09. What is the ratio of the Imports(as % of merchandise exports) of Nicaragua in 1974 to that in 1976?
Your answer should be compact. 0.83. What is the ratio of the Imports(as % of merchandise exports) in Sudan in 1974 to that in 1976?
Your answer should be compact. 2.9. What is the ratio of the Imports(as % of merchandise exports) in Middle East & North Africa (developing only) in 1974 to that in 1977?
Provide a short and direct response. 0.72. What is the ratio of the Imports(as % of merchandise exports) of Greece in 1974 to that in 1977?
Provide a succinct answer. 1.46. What is the ratio of the Imports(as % of merchandise exports) of Nicaragua in 1974 to that in 1977?
Provide a short and direct response. 0.79. What is the ratio of the Imports(as % of merchandise exports) in Sudan in 1974 to that in 1977?
Make the answer very short. 2.96. What is the ratio of the Imports(as % of merchandise exports) of Middle East & North Africa (developing only) in 1974 to that in 1997?
Offer a terse response. 0.67. What is the ratio of the Imports(as % of merchandise exports) in Greece in 1974 to that in 1997?
Provide a succinct answer. 2.83. What is the ratio of the Imports(as % of merchandise exports) in Nicaragua in 1974 to that in 1997?
Offer a very short reply. 0.89. What is the ratio of the Imports(as % of merchandise exports) of Sudan in 1974 to that in 1997?
Give a very brief answer. 0.41. What is the ratio of the Imports(as % of merchandise exports) in Middle East & North Africa (developing only) in 1974 to that in 1998?
Your answer should be very brief. 0.91. What is the ratio of the Imports(as % of merchandise exports) of Greece in 1974 to that in 1998?
Your response must be concise. 3.02. What is the ratio of the Imports(as % of merchandise exports) of Nicaragua in 1974 to that in 1998?
Your answer should be compact. 0.92. What is the ratio of the Imports(as % of merchandise exports) in Sudan in 1974 to that in 1998?
Ensure brevity in your answer.  0.65. What is the ratio of the Imports(as % of merchandise exports) of Middle East & North Africa (developing only) in 1974 to that in 1999?
Ensure brevity in your answer.  0.69. What is the ratio of the Imports(as % of merchandise exports) in Greece in 1974 to that in 1999?
Keep it short and to the point. 4. What is the ratio of the Imports(as % of merchandise exports) of Nicaragua in 1974 to that in 1999?
Provide a short and direct response. 1.32. What is the ratio of the Imports(as % of merchandise exports) of Sudan in 1974 to that in 1999?
Your answer should be compact. 0.54. What is the ratio of the Imports(as % of merchandise exports) in Middle East & North Africa (developing only) in 1975 to that in 1976?
Make the answer very short. 0.95. What is the ratio of the Imports(as % of merchandise exports) in Greece in 1975 to that in 1976?
Make the answer very short. 1.09. What is the ratio of the Imports(as % of merchandise exports) in Nicaragua in 1975 to that in 1976?
Your response must be concise. 1.1. What is the ratio of the Imports(as % of merchandise exports) in Sudan in 1975 to that in 1976?
Your response must be concise. 1.59. What is the ratio of the Imports(as % of merchandise exports) in Middle East & North Africa (developing only) in 1975 to that in 1977?
Provide a succinct answer. 0.83. What is the ratio of the Imports(as % of merchandise exports) of Greece in 1975 to that in 1977?
Your answer should be compact. 1.46. What is the ratio of the Imports(as % of merchandise exports) of Nicaragua in 1975 to that in 1977?
Give a very brief answer. 1.04. What is the ratio of the Imports(as % of merchandise exports) of Sudan in 1975 to that in 1977?
Your answer should be very brief. 1.62. What is the ratio of the Imports(as % of merchandise exports) in Middle East & North Africa (developing only) in 1975 to that in 1997?
Keep it short and to the point. 0.77. What is the ratio of the Imports(as % of merchandise exports) of Greece in 1975 to that in 1997?
Provide a short and direct response. 2.82. What is the ratio of the Imports(as % of merchandise exports) in Nicaragua in 1975 to that in 1997?
Give a very brief answer. 1.17. What is the ratio of the Imports(as % of merchandise exports) in Sudan in 1975 to that in 1997?
Offer a terse response. 0.22. What is the ratio of the Imports(as % of merchandise exports) of Middle East & North Africa (developing only) in 1975 to that in 1998?
Make the answer very short. 1.04. What is the ratio of the Imports(as % of merchandise exports) in Greece in 1975 to that in 1998?
Offer a very short reply. 3.01. What is the ratio of the Imports(as % of merchandise exports) in Nicaragua in 1975 to that in 1998?
Your answer should be compact. 1.21. What is the ratio of the Imports(as % of merchandise exports) in Sudan in 1975 to that in 1998?
Give a very brief answer. 0.36. What is the ratio of the Imports(as % of merchandise exports) in Middle East & North Africa (developing only) in 1975 to that in 1999?
Offer a terse response. 0.79. What is the ratio of the Imports(as % of merchandise exports) of Greece in 1975 to that in 1999?
Provide a short and direct response. 3.98. What is the ratio of the Imports(as % of merchandise exports) in Nicaragua in 1975 to that in 1999?
Keep it short and to the point. 1.73. What is the ratio of the Imports(as % of merchandise exports) of Sudan in 1975 to that in 1999?
Your response must be concise. 0.3. What is the ratio of the Imports(as % of merchandise exports) in Middle East & North Africa (developing only) in 1976 to that in 1977?
Offer a very short reply. 0.88. What is the ratio of the Imports(as % of merchandise exports) in Greece in 1976 to that in 1977?
Offer a very short reply. 1.34. What is the ratio of the Imports(as % of merchandise exports) in Nicaragua in 1976 to that in 1977?
Provide a succinct answer. 0.95. What is the ratio of the Imports(as % of merchandise exports) in Sudan in 1976 to that in 1977?
Make the answer very short. 1.02. What is the ratio of the Imports(as % of merchandise exports) in Middle East & North Africa (developing only) in 1976 to that in 1997?
Provide a succinct answer. 0.81. What is the ratio of the Imports(as % of merchandise exports) in Greece in 1976 to that in 1997?
Make the answer very short. 2.6. What is the ratio of the Imports(as % of merchandise exports) of Nicaragua in 1976 to that in 1997?
Your response must be concise. 1.07. What is the ratio of the Imports(as % of merchandise exports) in Sudan in 1976 to that in 1997?
Your answer should be very brief. 0.14. What is the ratio of the Imports(as % of merchandise exports) of Middle East & North Africa (developing only) in 1976 to that in 1998?
Ensure brevity in your answer.  1.1. What is the ratio of the Imports(as % of merchandise exports) of Greece in 1976 to that in 1998?
Your response must be concise. 2.77. What is the ratio of the Imports(as % of merchandise exports) in Nicaragua in 1976 to that in 1998?
Your answer should be compact. 1.1. What is the ratio of the Imports(as % of merchandise exports) of Sudan in 1976 to that in 1998?
Provide a short and direct response. 0.22. What is the ratio of the Imports(as % of merchandise exports) in Middle East & North Africa (developing only) in 1976 to that in 1999?
Offer a very short reply. 0.84. What is the ratio of the Imports(as % of merchandise exports) of Greece in 1976 to that in 1999?
Provide a succinct answer. 3.67. What is the ratio of the Imports(as % of merchandise exports) of Nicaragua in 1976 to that in 1999?
Your answer should be compact. 1.58. What is the ratio of the Imports(as % of merchandise exports) of Sudan in 1976 to that in 1999?
Ensure brevity in your answer.  0.19. What is the ratio of the Imports(as % of merchandise exports) of Middle East & North Africa (developing only) in 1977 to that in 1997?
Provide a short and direct response. 0.93. What is the ratio of the Imports(as % of merchandise exports) in Greece in 1977 to that in 1997?
Give a very brief answer. 1.94. What is the ratio of the Imports(as % of merchandise exports) in Nicaragua in 1977 to that in 1997?
Make the answer very short. 1.13. What is the ratio of the Imports(as % of merchandise exports) of Sudan in 1977 to that in 1997?
Keep it short and to the point. 0.14. What is the ratio of the Imports(as % of merchandise exports) of Middle East & North Africa (developing only) in 1977 to that in 1998?
Make the answer very short. 1.26. What is the ratio of the Imports(as % of merchandise exports) of Greece in 1977 to that in 1998?
Your answer should be very brief. 2.06. What is the ratio of the Imports(as % of merchandise exports) in Nicaragua in 1977 to that in 1998?
Give a very brief answer. 1.16. What is the ratio of the Imports(as % of merchandise exports) of Sudan in 1977 to that in 1998?
Your response must be concise. 0.22. What is the ratio of the Imports(as % of merchandise exports) of Middle East & North Africa (developing only) in 1977 to that in 1999?
Keep it short and to the point. 0.96. What is the ratio of the Imports(as % of merchandise exports) in Greece in 1977 to that in 1999?
Ensure brevity in your answer.  2.73. What is the ratio of the Imports(as % of merchandise exports) of Nicaragua in 1977 to that in 1999?
Offer a terse response. 1.67. What is the ratio of the Imports(as % of merchandise exports) of Sudan in 1977 to that in 1999?
Provide a succinct answer. 0.18. What is the ratio of the Imports(as % of merchandise exports) in Middle East & North Africa (developing only) in 1997 to that in 1998?
Provide a short and direct response. 1.36. What is the ratio of the Imports(as % of merchandise exports) of Greece in 1997 to that in 1998?
Give a very brief answer. 1.07. What is the ratio of the Imports(as % of merchandise exports) of Nicaragua in 1997 to that in 1998?
Your answer should be compact. 1.03. What is the ratio of the Imports(as % of merchandise exports) in Sudan in 1997 to that in 1998?
Your answer should be compact. 1.6. What is the ratio of the Imports(as % of merchandise exports) in Middle East & North Africa (developing only) in 1997 to that in 1999?
Offer a very short reply. 1.03. What is the ratio of the Imports(as % of merchandise exports) in Greece in 1997 to that in 1999?
Provide a succinct answer. 1.41. What is the ratio of the Imports(as % of merchandise exports) of Nicaragua in 1997 to that in 1999?
Your answer should be very brief. 1.48. What is the ratio of the Imports(as % of merchandise exports) of Sudan in 1997 to that in 1999?
Offer a very short reply. 1.33. What is the ratio of the Imports(as % of merchandise exports) in Middle East & North Africa (developing only) in 1998 to that in 1999?
Ensure brevity in your answer.  0.76. What is the ratio of the Imports(as % of merchandise exports) in Greece in 1998 to that in 1999?
Your answer should be very brief. 1.32. What is the ratio of the Imports(as % of merchandise exports) of Nicaragua in 1998 to that in 1999?
Your answer should be compact. 1.44. What is the ratio of the Imports(as % of merchandise exports) of Sudan in 1998 to that in 1999?
Make the answer very short. 0.83. What is the difference between the highest and the second highest Imports(as % of merchandise exports) of Middle East & North Africa (developing only)?
Keep it short and to the point. 0.17. What is the difference between the highest and the second highest Imports(as % of merchandise exports) of Greece?
Your answer should be compact. 0.08. What is the difference between the highest and the second highest Imports(as % of merchandise exports) of Nicaragua?
Your answer should be compact. 0.49. What is the difference between the highest and the second highest Imports(as % of merchandise exports) of Sudan?
Your answer should be compact. 4.09. What is the difference between the highest and the lowest Imports(as % of merchandise exports) of Middle East & North Africa (developing only)?
Provide a succinct answer. 1.94. What is the difference between the highest and the lowest Imports(as % of merchandise exports) of Greece?
Provide a short and direct response. 16.66. What is the difference between the highest and the lowest Imports(as % of merchandise exports) of Nicaragua?
Your response must be concise. 6.05. What is the difference between the highest and the lowest Imports(as % of merchandise exports) of Sudan?
Your answer should be compact. 14.29. 